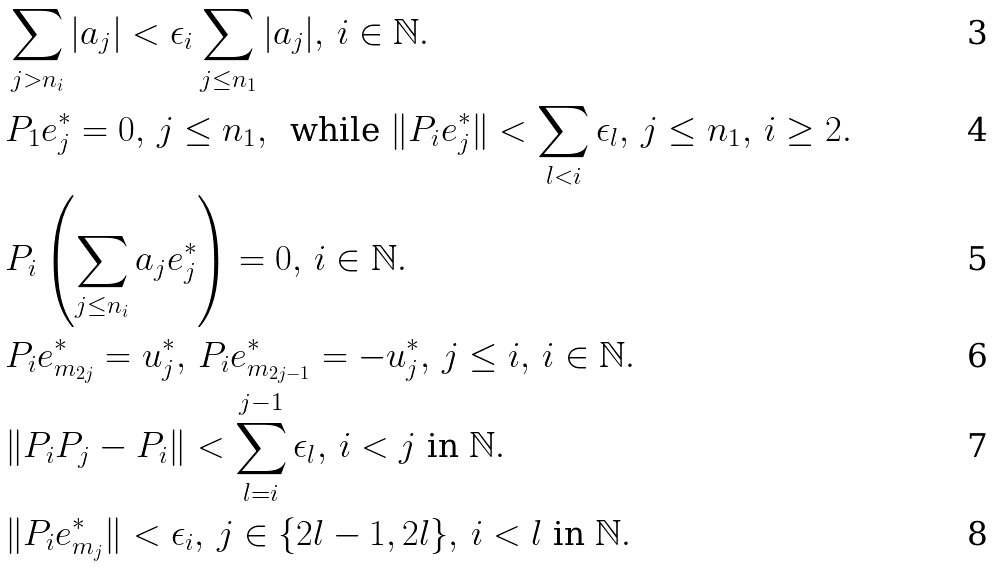<formula> <loc_0><loc_0><loc_500><loc_500>& \sum _ { j > n _ { i } } | a _ { j } | < \epsilon _ { i } \sum _ { j \leq n _ { 1 } } | a _ { j } | , \, i \in \mathbb { N } . \\ & P _ { 1 } e _ { j } ^ { * } = 0 , \, j \leq n _ { 1 } , \, \text { while } \| P _ { i } e _ { j } ^ { * } \| < \sum _ { l < i } \epsilon _ { l } , \, j \leq n _ { 1 } , \, i \geq 2 . \\ & P _ { i } \left ( \sum _ { j \leq n _ { i } } a _ { j } e _ { j } ^ { * } \right ) = 0 , \, i \in \mathbb { N } . \\ & P _ { i } e _ { m _ { 2 j } } ^ { * } = u _ { j } ^ { * } , \, P _ { i } e _ { m _ { 2 j - 1 } } ^ { * } = - u _ { j } ^ { * } , \, j \leq i , \, i \in \mathbb { N } . \\ & \| P _ { i } P _ { j } - P _ { i } \| < \sum _ { l = i } ^ { j - 1 } \epsilon _ { l } , \, i < j \text { in } \mathbb { N } . \\ & \| P _ { i } e _ { m _ { j } } ^ { * } \| < \epsilon _ { i } , \, j \in \{ 2 l - 1 , 2 l \} , \, i < l \text { in } \mathbb { N } .</formula> 